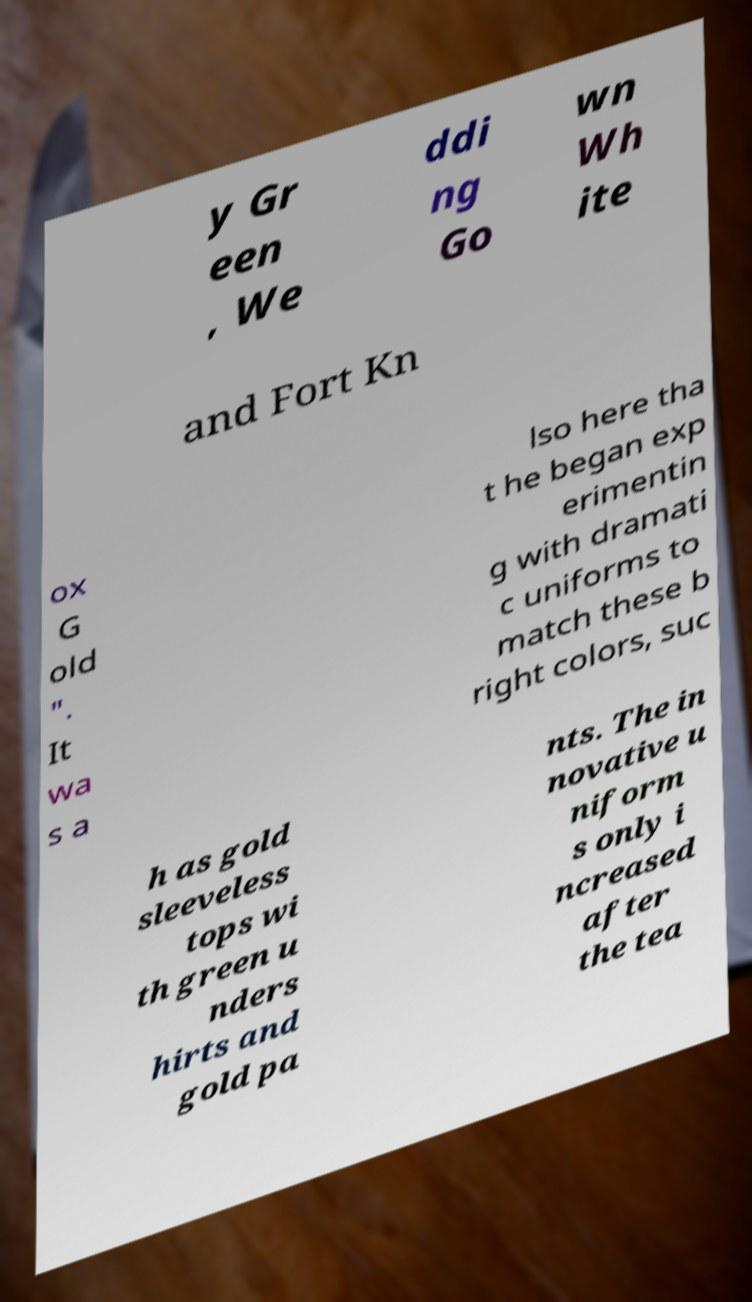Can you read and provide the text displayed in the image?This photo seems to have some interesting text. Can you extract and type it out for me? y Gr een , We ddi ng Go wn Wh ite and Fort Kn ox G old ". It wa s a lso here tha t he began exp erimentin g with dramati c uniforms to match these b right colors, suc h as gold sleeveless tops wi th green u nders hirts and gold pa nts. The in novative u niform s only i ncreased after the tea 